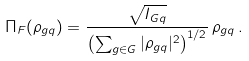<formula> <loc_0><loc_0><loc_500><loc_500>\Pi _ { F } ( \rho _ { g q } ) = \frac { \sqrt { I _ { G q } } } { \left ( \sum _ { g \in G } | \rho _ { g { q } } | ^ { 2 } \right ) ^ { 1 / 2 } } \, \rho _ { g { q } } \, .</formula> 